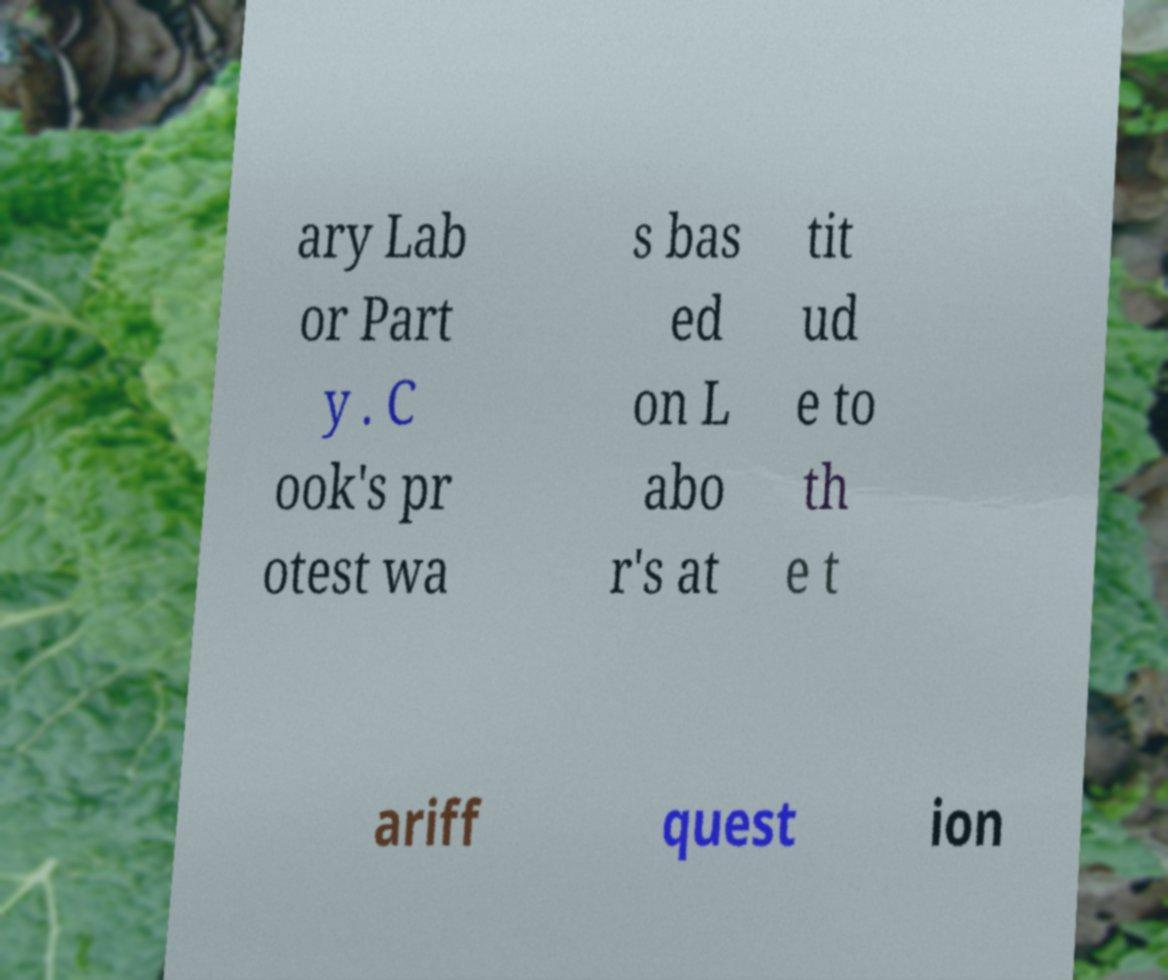For documentation purposes, I need the text within this image transcribed. Could you provide that? ary Lab or Part y . C ook's pr otest wa s bas ed on L abo r's at tit ud e to th e t ariff quest ion 